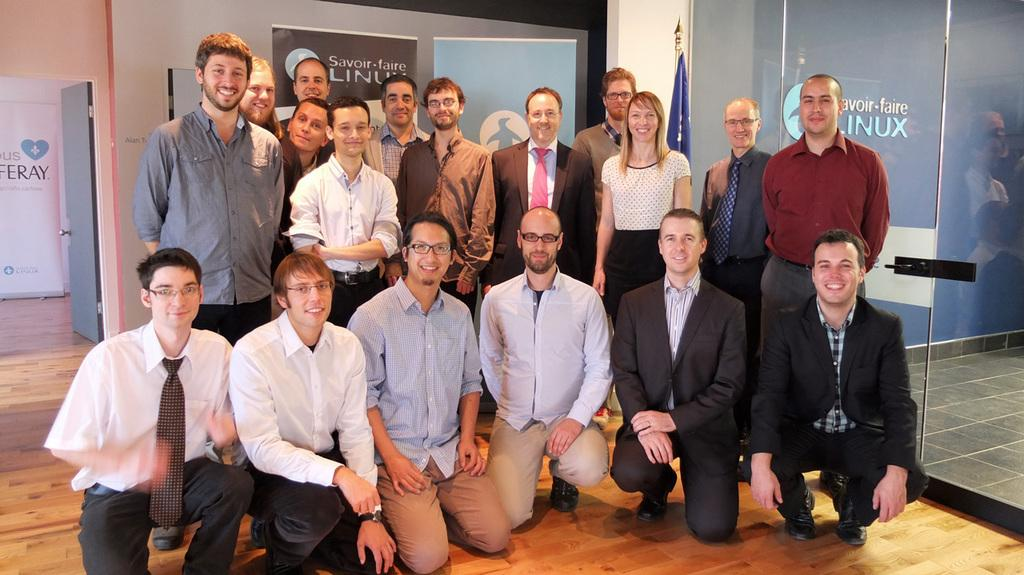How many people are in the image? There is a group of people in the image, but the exact number is not specified. What is the facial expression of the people in the image? The people in the image are smiling. What is the position of some of the people in the image? Some people are standing on the floor. What can be seen in the background of the image? In the background of the image, there is a flag, a door, posters, walls, and a glass. Can you tell me how many people are writing on the walls in the image? There is no mention of people writing on the walls in the image; the people are smiling and standing on the floor. Is there a body of water in the image where people can swim? There is no body of water or swimming activity depicted in the image. 